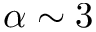<formula> <loc_0><loc_0><loc_500><loc_500>\alpha \sim 3</formula> 